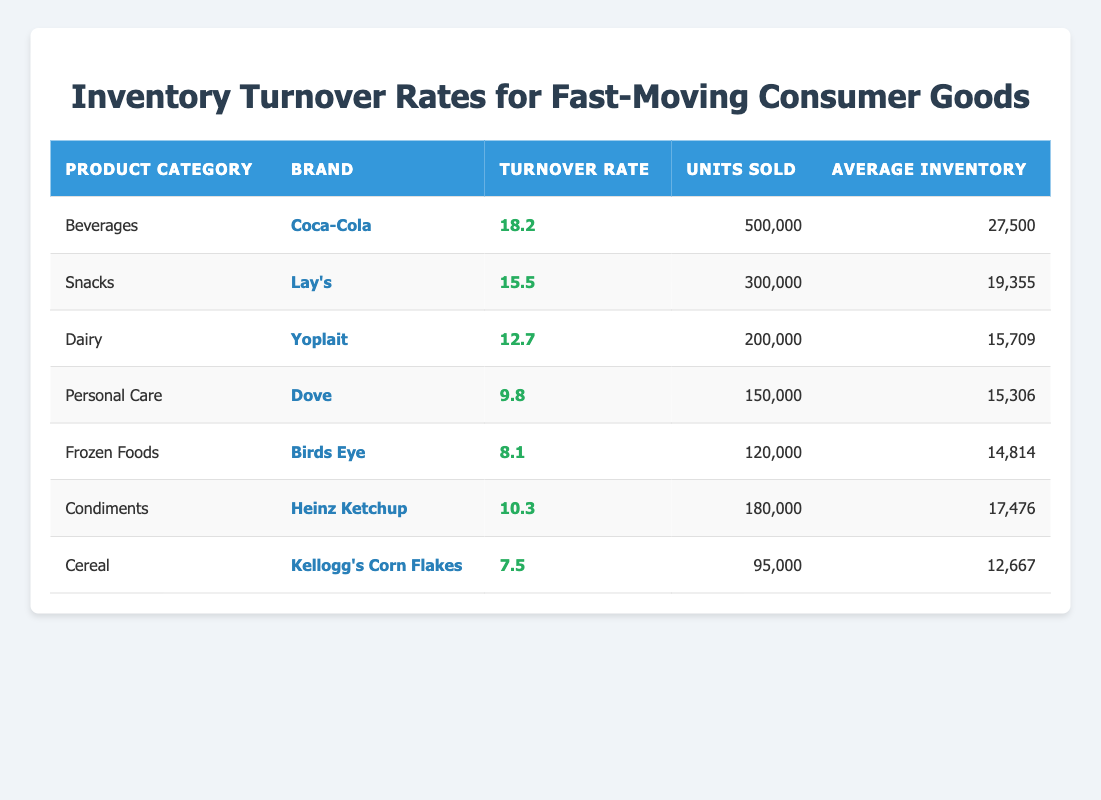What is the turnover rate for Coca-Cola? The table lists the turnover rate for Coca-Cola directly in the column next to its brand name, which is 18.2.
Answer: 18.2 Which product category has the highest inventory turnover rate? Looking through the turnover rates listed, Beverages has the highest rate at 18.2 for Coca-Cola, which is higher than any other product category.
Answer: Beverages How many units were sold for Lay's? The data shows that Lay's sold a total of 300,000 units, which is specified in the corresponding column.
Answer: 300,000 What is the average inventory for Yoplait? Referring to the column for average inventory directly adjacent to Yoplait, the average inventory is 15,709.
Answer: 15,709 Which of the brands listed has a turnover rate of more than 10? The brands listed with a turnover rate of more than 10 include Coca-Cola (18.2), Lay's (15.5), and Heinz Ketchup (10.3).
Answer: Coca-Cola, Lay's, Heinz Ketchup What is the total turnover rate of all products combined? To find the total turnover rate of all products, add the turnover rates of each product: 18.2 + 15.5 + 12.7 + 9.8 + 8.1 + 10.3 + 7.5 = 81.1.
Answer: 81.1 Is Yoplait's turnover rate higher than that of Dove? By comparing the turnover rates, Yoplait has a turnover rate of 12.7 and Dove has a turnover rate of 9.8. Since 12.7 is greater than 9.8, the statement is true.
Answer: Yes What is the average turnover rate for the snacks category? The only snack product listed is Lay's with a turnover rate of 15.5; since there is only one entry, the average is also 15.5.
Answer: 15.5 How many more units were sold of Coca-Cola compared to Birds Eye? Coca-Cola sold 500,000 units while Birds Eye sold 120,000 units. The difference is 500,000 - 120,000 = 380,000 units.
Answer: 380,000 Which product category has the lowest average inventory? Looking at the average inventory column, Kellogg's Corn Flakes has the lowest average inventory at 12,667.
Answer: Cereal 